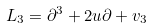Convert formula to latex. <formula><loc_0><loc_0><loc_500><loc_500>L _ { 3 } = \partial ^ { 3 } + 2 u \partial + v _ { 3 }</formula> 